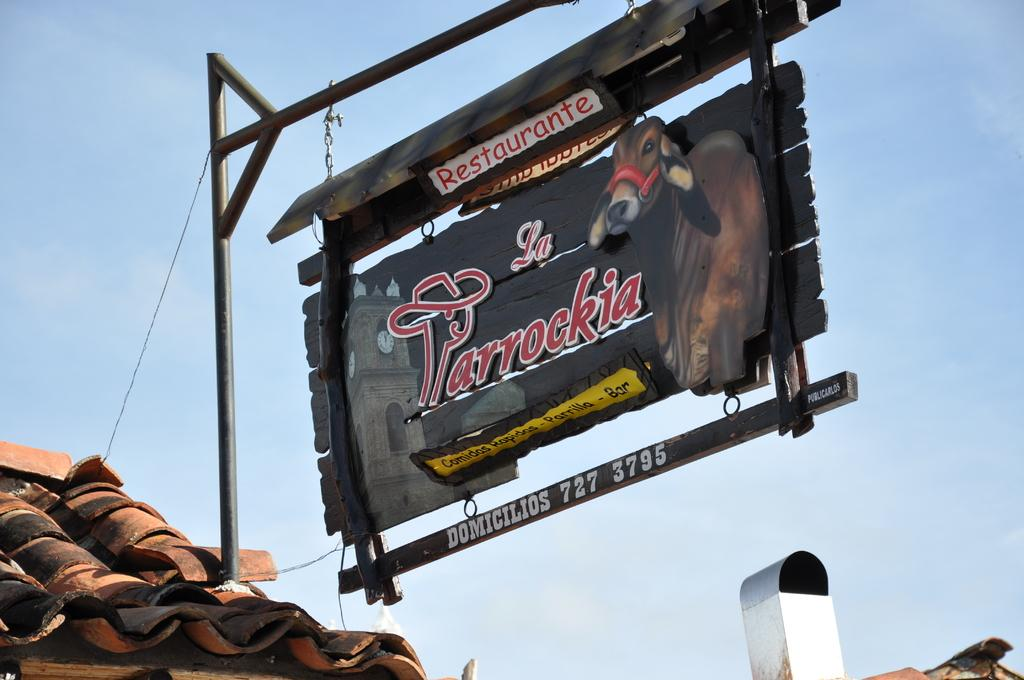What is on the pole in the image? There is a board on a pole in the image. What is depicted on the board? The board has a picture of a cow on it. What else can be seen on the board? There is text on the board. Where is the board located? The board is on a roof. What is visible in the background of the image? The sky is visible in the image. How would you describe the weather based on the sky? The sky appears cloudy in the image. How many dogs are playing in the garden in the image? There are no dogs or gardens present in the image. 